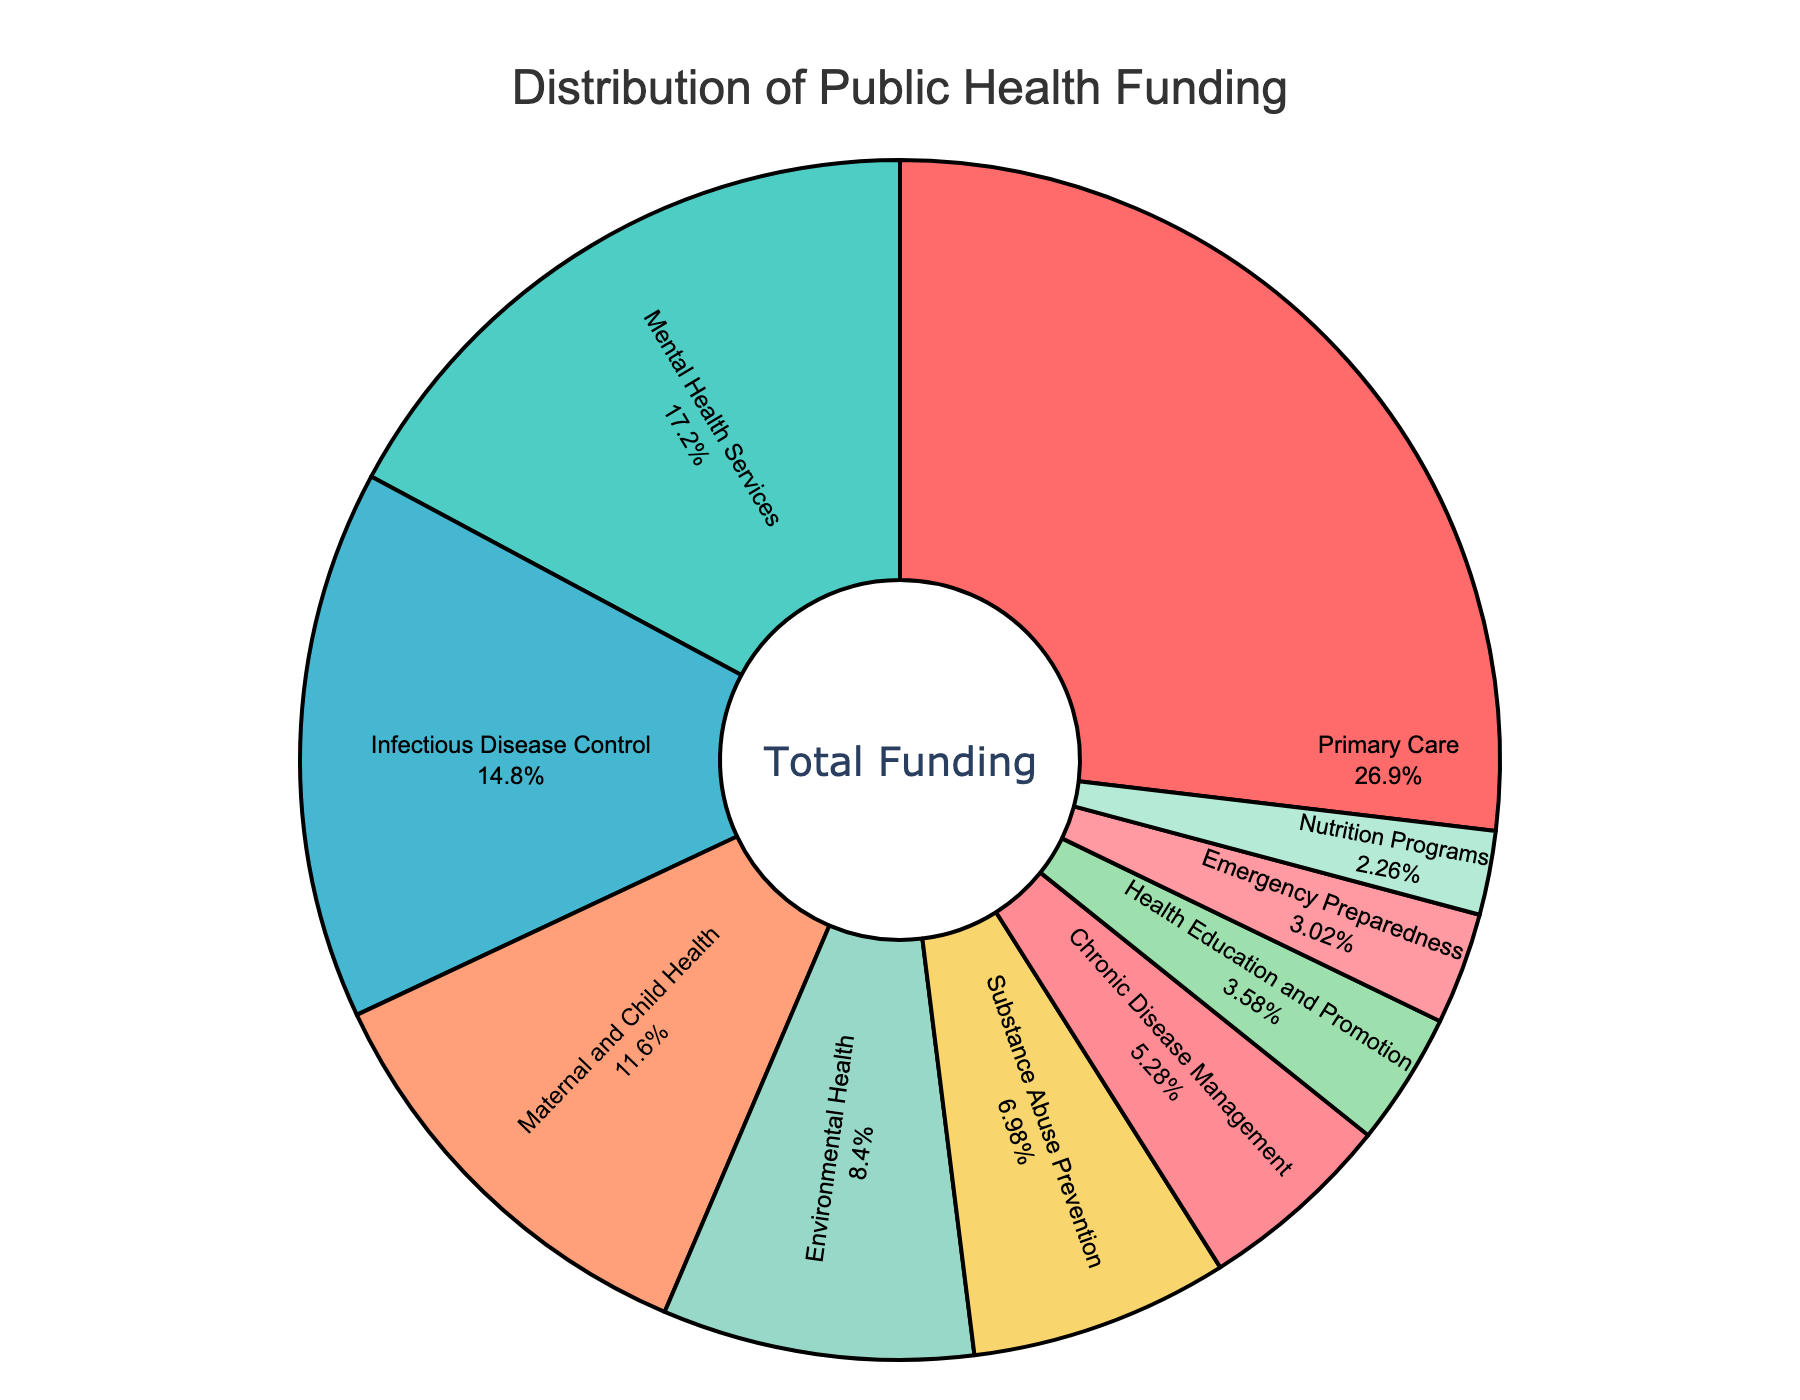What percentage of the funding goes to the two largest health sectors combined? The largest health sector is Primary Care with 28.5% and the second largest is Mental Health Services with 18.2%. To find the combined percentage, sum these two values: 28.5% + 18.2% = 46.7%
Answer: 46.7% How much more funding does Primary Care receive compared to Maternal and Child Health? Primary Care receives 28.5% of the funding, while Maternal and Child Health receives 12.3%. The difference is calculated by subtracting the smaller percentage from the larger one: 28.5% - 12.3% = 16.2%
Answer: 16.2% Which health sector receives the least amount of funding, and what is its percentage? By observing the pie chart, Nutrition Programs receives the least amount of funding. The percentage for Nutrition Programs is 2.4%
Answer: Nutrition Programs, 2.4% What is the total funding percentage allocated to services related to disease control (Infectious Disease Control and Chronic Disease Management)? Infectious Disease Control receives 15.7% and Chronic Disease Management gets 5.6%. Summing these two percentages gives: 15.7% + 5.6% = 21.3%
Answer: 21.3% Does Mental Health Services receive more or less funding than Substance Abuse Prevention and Health Education and Promotion combined? Mental Health Services receives 18.2%. Substance Abuse Prevention and Health Education and Promotion receive 7.4% and 3.8% respectively. Their combined funding is 7.4% + 3.8% = 11.2%. Comparing 18.2% to 11.2%, Mental Health Services receives more funding
Answer: More Which sectors are represented by blue and green colors, and what are their corresponding percentages? By visual attributes, the sectors represented by blue and green colors can be identified. The sector in blue is Chronic Disease Management with 5.6% and the sector in green is Primary Care with 28.5%
Answer: Chronic Disease Management, 5.6%; Primary Care, 28.5% What is the combined funding percentage of all sectors receiving less than 10% funding individually? Sectors receiving less than 10% are: Environmental Health (8.9%), Substance Abuse Prevention (7.4%), Chronic Disease Management (5.6%), Health Education and Promotion (3.8%), Emergency Preparedness (3.2%), and Nutrition Programs (2.4%). Adding these gives: 8.9% + 7.4% + 5.6% + 3.8% + 3.2% + 2.4% = 31.3%
Answer: 31.3% Is the funding for Emergency Preparedness greater than the combined funding for Health Education and Promotion and Nutrition Programs? Emergency Preparedness has 3.2%. Health Education and Promotion gets 3.8% and Nutrition Programs 2.4%. Their combined funding is 3.8% + 2.4% = 6.2%. Comparing 3.2% to 6.2%, Emergency Preparedness receives less funding
Answer: Less 